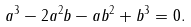Convert formula to latex. <formula><loc_0><loc_0><loc_500><loc_500>a ^ { 3 } - 2 a ^ { 2 } b - a b ^ { 2 } + b ^ { 3 } = 0 .</formula> 